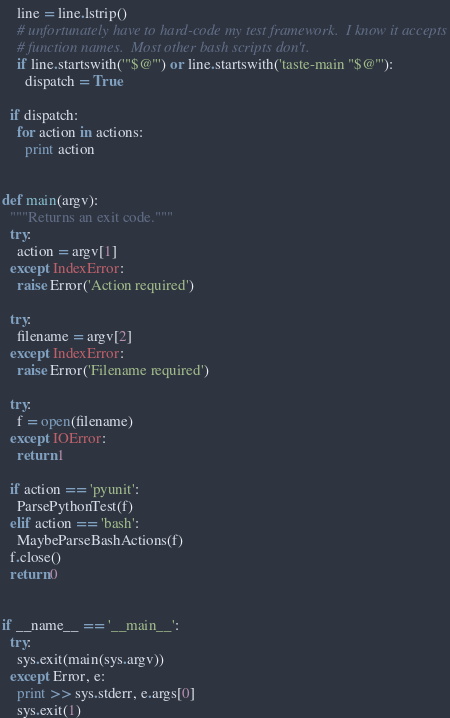Convert code to text. <code><loc_0><loc_0><loc_500><loc_500><_Python_>    line = line.lstrip()
    # unfortunately have to hard-code my test framework.  I know it accepts
    # function names.  Most other bash scripts don't.
    if line.startswith('"$@"') or line.startswith('taste-main "$@"'):
      dispatch = True

  if dispatch:
    for action in actions:
      print action


def main(argv):
  """Returns an exit code."""
  try:
    action = argv[1]
  except IndexError:
    raise Error('Action required')

  try:
    filename = argv[2]
  except IndexError:
    raise Error('Filename required')

  try:
    f = open(filename)
  except IOError:
    return 1

  if action == 'pyunit':
    ParsePythonTest(f)
  elif action == 'bash':
    MaybeParseBashActions(f)
  f.close()
  return 0


if __name__ == '__main__':
  try:
    sys.exit(main(sys.argv))
  except Error, e:
    print >> sys.stderr, e.args[0]
    sys.exit(1)
</code> 